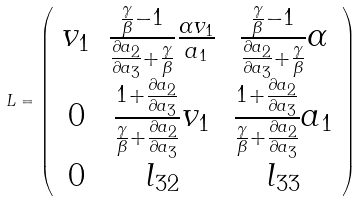<formula> <loc_0><loc_0><loc_500><loc_500>L = \left ( \begin{array} { c c c } v _ { 1 } & \frac { \frac { \gamma } { \beta } - 1 } { \frac { \partial a _ { 2 } } { \partial a _ { 3 } } + \frac { \gamma } { \beta } } \frac { \alpha v _ { 1 } } { a _ { 1 } } & \frac { \frac { \gamma } { \beta } - 1 } { \frac { \partial a _ { 2 } } { \partial a _ { 3 } } + \frac { \gamma } { \beta } } \alpha \\ 0 & \frac { 1 + \frac { \partial a _ { 2 } } { \partial a _ { 3 } } } { \frac { \gamma } { \beta } + \frac { \partial a _ { 2 } } { \partial a _ { 3 } } } v _ { 1 } & \frac { 1 + \frac { \partial a _ { 2 } } { \partial a _ { 3 } } } { \frac { \gamma } { \beta } + \frac { \partial a _ { 2 } } { \partial a _ { 3 } } } a _ { 1 } \\ 0 & l _ { 3 2 } & l _ { 3 3 } \\ \end{array} \right )</formula> 